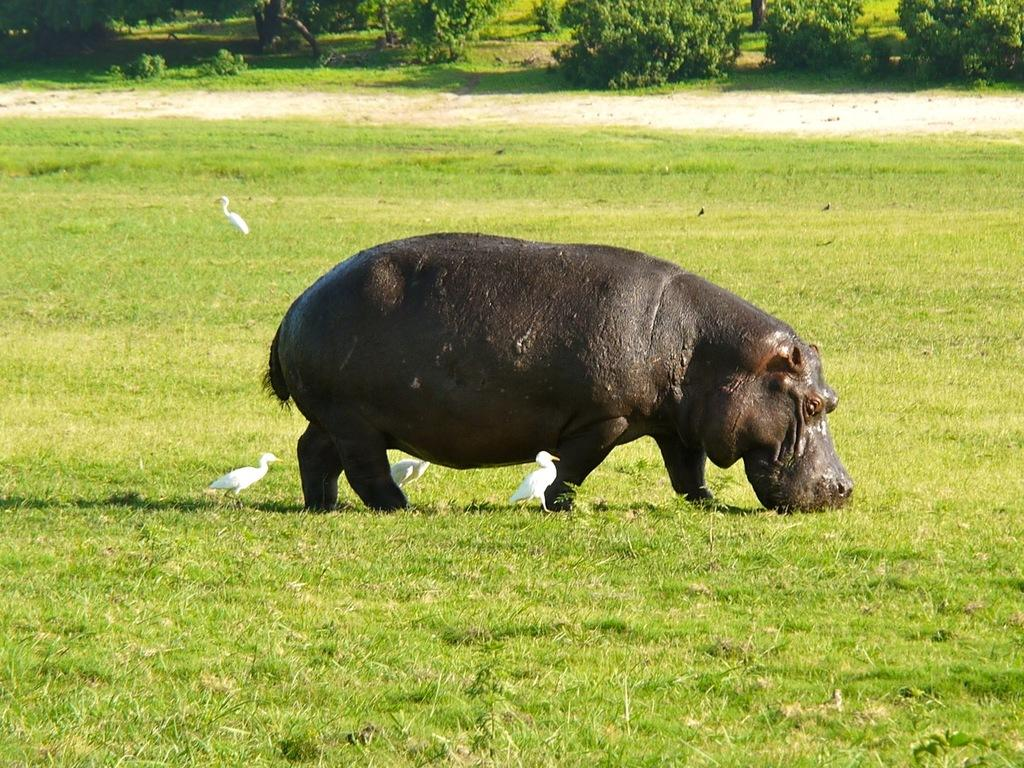What type of animal is in the image? There is a hippopotamus in the image. What other living creatures can be seen in the image? There are birds in the image. Where are the birds located in the image? The birds are on the grass in the image. What can be seen in the background of the image? There are trees in the background of the image. What type of hat is the hippopotamus wearing in the image? The hippopotamus is not wearing a hat in the image. Can you see any cables or wires in the image? There are no cables or wires visible in the image. 